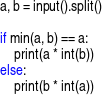<code> <loc_0><loc_0><loc_500><loc_500><_Python_>a, b = input().split()

if min(a, b) == a:
    print(a * int(b))
else:
    print(b * int(a))
</code> 